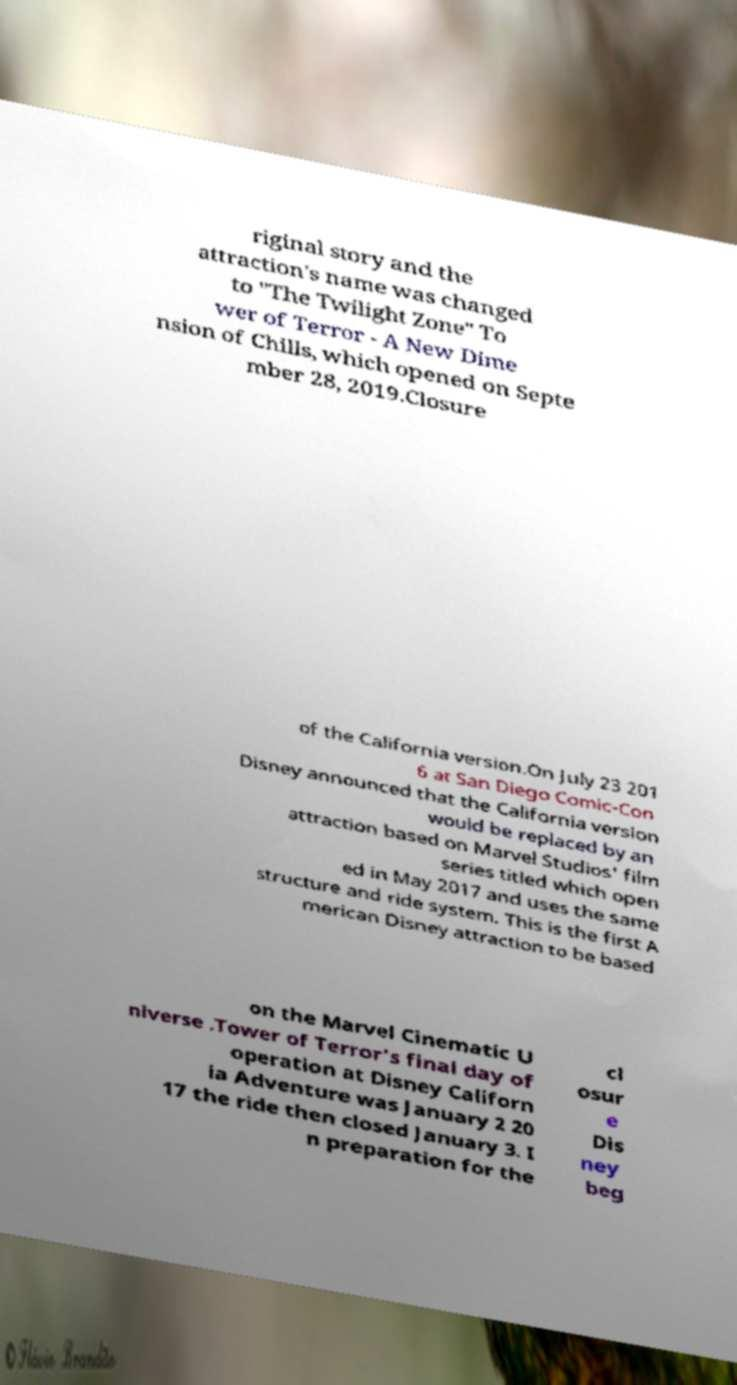I need the written content from this picture converted into text. Can you do that? riginal story and the attraction's name was changed to "The Twilight Zone" To wer of Terror - A New Dime nsion of Chills, which opened on Septe mber 28, 2019.Closure of the California version.On July 23 201 6 at San Diego Comic-Con Disney announced that the California version would be replaced by an attraction based on Marvel Studios' film series titled which open ed in May 2017 and uses the same structure and ride system. This is the first A merican Disney attraction to be based on the Marvel Cinematic U niverse .Tower of Terror's final day of operation at Disney Californ ia Adventure was January 2 20 17 the ride then closed January 3. I n preparation for the cl osur e Dis ney beg 